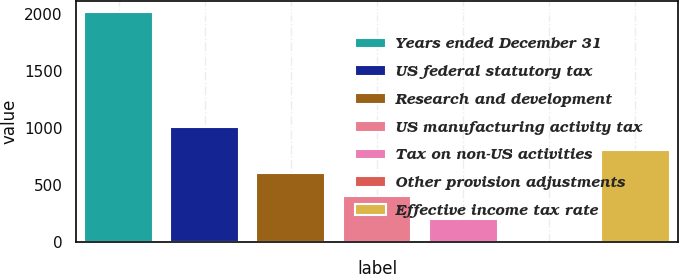Convert chart. <chart><loc_0><loc_0><loc_500><loc_500><bar_chart><fcel>Years ended December 31<fcel>US federal statutory tax<fcel>Research and development<fcel>US manufacturing activity tax<fcel>Tax on non-US activities<fcel>Other provision adjustments<fcel>Effective income tax rate<nl><fcel>2015<fcel>1007.7<fcel>604.78<fcel>403.32<fcel>201.86<fcel>0.4<fcel>806.24<nl></chart> 